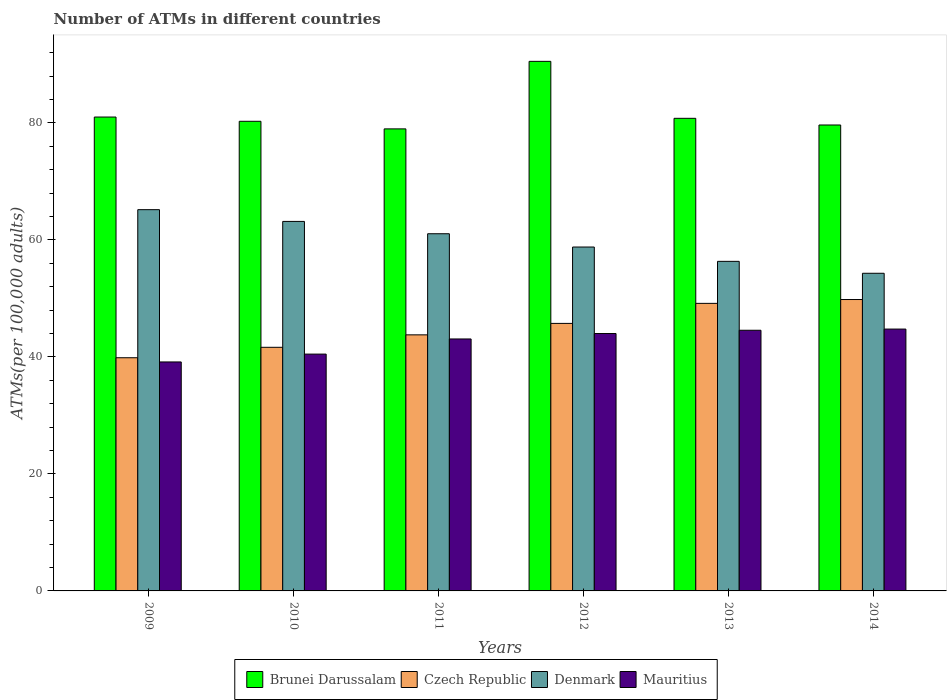How many different coloured bars are there?
Ensure brevity in your answer.  4. How many groups of bars are there?
Make the answer very short. 6. Are the number of bars per tick equal to the number of legend labels?
Provide a succinct answer. Yes. Are the number of bars on each tick of the X-axis equal?
Give a very brief answer. Yes. What is the label of the 6th group of bars from the left?
Your response must be concise. 2014. What is the number of ATMs in Czech Republic in 2014?
Provide a short and direct response. 49.8. Across all years, what is the maximum number of ATMs in Czech Republic?
Offer a terse response. 49.8. Across all years, what is the minimum number of ATMs in Mauritius?
Make the answer very short. 39.13. In which year was the number of ATMs in Denmark maximum?
Provide a succinct answer. 2009. In which year was the number of ATMs in Brunei Darussalam minimum?
Make the answer very short. 2011. What is the total number of ATMs in Denmark in the graph?
Give a very brief answer. 358.73. What is the difference between the number of ATMs in Brunei Darussalam in 2010 and that in 2011?
Provide a short and direct response. 1.3. What is the difference between the number of ATMs in Denmark in 2014 and the number of ATMs in Mauritius in 2009?
Keep it short and to the point. 15.15. What is the average number of ATMs in Denmark per year?
Ensure brevity in your answer.  59.79. In the year 2012, what is the difference between the number of ATMs in Mauritius and number of ATMs in Brunei Darussalam?
Offer a very short reply. -46.52. In how many years, is the number of ATMs in Czech Republic greater than 68?
Make the answer very short. 0. What is the ratio of the number of ATMs in Brunei Darussalam in 2013 to that in 2014?
Provide a short and direct response. 1.01. Is the number of ATMs in Czech Republic in 2009 less than that in 2013?
Your answer should be compact. Yes. What is the difference between the highest and the second highest number of ATMs in Denmark?
Provide a short and direct response. 2.01. What is the difference between the highest and the lowest number of ATMs in Mauritius?
Make the answer very short. 5.62. Is the sum of the number of ATMs in Czech Republic in 2009 and 2012 greater than the maximum number of ATMs in Brunei Darussalam across all years?
Offer a terse response. No. Is it the case that in every year, the sum of the number of ATMs in Brunei Darussalam and number of ATMs in Denmark is greater than the sum of number of ATMs in Mauritius and number of ATMs in Czech Republic?
Provide a succinct answer. No. What does the 2nd bar from the left in 2010 represents?
Your answer should be compact. Czech Republic. How many years are there in the graph?
Keep it short and to the point. 6. Does the graph contain grids?
Offer a terse response. No. What is the title of the graph?
Ensure brevity in your answer.  Number of ATMs in different countries. What is the label or title of the Y-axis?
Your answer should be compact. ATMs(per 100,0 adults). What is the ATMs(per 100,000 adults) of Brunei Darussalam in 2009?
Make the answer very short. 80.99. What is the ATMs(per 100,000 adults) of Czech Republic in 2009?
Provide a short and direct response. 39.85. What is the ATMs(per 100,000 adults) in Denmark in 2009?
Keep it short and to the point. 65.16. What is the ATMs(per 100,000 adults) in Mauritius in 2009?
Provide a short and direct response. 39.13. What is the ATMs(per 100,000 adults) in Brunei Darussalam in 2010?
Provide a short and direct response. 80.26. What is the ATMs(per 100,000 adults) of Czech Republic in 2010?
Your answer should be very brief. 41.63. What is the ATMs(per 100,000 adults) in Denmark in 2010?
Keep it short and to the point. 63.15. What is the ATMs(per 100,000 adults) of Mauritius in 2010?
Your answer should be compact. 40.47. What is the ATMs(per 100,000 adults) in Brunei Darussalam in 2011?
Give a very brief answer. 78.96. What is the ATMs(per 100,000 adults) in Czech Republic in 2011?
Your response must be concise. 43.76. What is the ATMs(per 100,000 adults) in Denmark in 2011?
Your response must be concise. 61.04. What is the ATMs(per 100,000 adults) of Mauritius in 2011?
Ensure brevity in your answer.  43.06. What is the ATMs(per 100,000 adults) of Brunei Darussalam in 2012?
Offer a terse response. 90.5. What is the ATMs(per 100,000 adults) of Czech Republic in 2012?
Provide a succinct answer. 45.72. What is the ATMs(per 100,000 adults) of Denmark in 2012?
Provide a succinct answer. 58.77. What is the ATMs(per 100,000 adults) in Mauritius in 2012?
Give a very brief answer. 43.99. What is the ATMs(per 100,000 adults) of Brunei Darussalam in 2013?
Offer a terse response. 80.77. What is the ATMs(per 100,000 adults) of Czech Republic in 2013?
Give a very brief answer. 49.14. What is the ATMs(per 100,000 adults) of Denmark in 2013?
Keep it short and to the point. 56.32. What is the ATMs(per 100,000 adults) in Mauritius in 2013?
Offer a very short reply. 44.55. What is the ATMs(per 100,000 adults) in Brunei Darussalam in 2014?
Offer a terse response. 79.63. What is the ATMs(per 100,000 adults) of Czech Republic in 2014?
Provide a succinct answer. 49.8. What is the ATMs(per 100,000 adults) in Denmark in 2014?
Your response must be concise. 54.29. What is the ATMs(per 100,000 adults) in Mauritius in 2014?
Your response must be concise. 44.75. Across all years, what is the maximum ATMs(per 100,000 adults) in Brunei Darussalam?
Your answer should be very brief. 90.5. Across all years, what is the maximum ATMs(per 100,000 adults) in Czech Republic?
Offer a terse response. 49.8. Across all years, what is the maximum ATMs(per 100,000 adults) of Denmark?
Offer a very short reply. 65.16. Across all years, what is the maximum ATMs(per 100,000 adults) in Mauritius?
Offer a terse response. 44.75. Across all years, what is the minimum ATMs(per 100,000 adults) of Brunei Darussalam?
Provide a succinct answer. 78.96. Across all years, what is the minimum ATMs(per 100,000 adults) in Czech Republic?
Give a very brief answer. 39.85. Across all years, what is the minimum ATMs(per 100,000 adults) in Denmark?
Ensure brevity in your answer.  54.29. Across all years, what is the minimum ATMs(per 100,000 adults) in Mauritius?
Your answer should be compact. 39.13. What is the total ATMs(per 100,000 adults) in Brunei Darussalam in the graph?
Your answer should be very brief. 491.11. What is the total ATMs(per 100,000 adults) in Czech Republic in the graph?
Your answer should be compact. 269.91. What is the total ATMs(per 100,000 adults) in Denmark in the graph?
Your response must be concise. 358.73. What is the total ATMs(per 100,000 adults) in Mauritius in the graph?
Your answer should be compact. 255.95. What is the difference between the ATMs(per 100,000 adults) in Brunei Darussalam in 2009 and that in 2010?
Keep it short and to the point. 0.73. What is the difference between the ATMs(per 100,000 adults) of Czech Republic in 2009 and that in 2010?
Give a very brief answer. -1.78. What is the difference between the ATMs(per 100,000 adults) of Denmark in 2009 and that in 2010?
Ensure brevity in your answer.  2.01. What is the difference between the ATMs(per 100,000 adults) in Mauritius in 2009 and that in 2010?
Keep it short and to the point. -1.34. What is the difference between the ATMs(per 100,000 adults) of Brunei Darussalam in 2009 and that in 2011?
Make the answer very short. 2.02. What is the difference between the ATMs(per 100,000 adults) in Czech Republic in 2009 and that in 2011?
Give a very brief answer. -3.91. What is the difference between the ATMs(per 100,000 adults) in Denmark in 2009 and that in 2011?
Provide a short and direct response. 4.11. What is the difference between the ATMs(per 100,000 adults) of Mauritius in 2009 and that in 2011?
Provide a succinct answer. -3.93. What is the difference between the ATMs(per 100,000 adults) of Brunei Darussalam in 2009 and that in 2012?
Offer a terse response. -9.52. What is the difference between the ATMs(per 100,000 adults) in Czech Republic in 2009 and that in 2012?
Make the answer very short. -5.87. What is the difference between the ATMs(per 100,000 adults) of Denmark in 2009 and that in 2012?
Provide a short and direct response. 6.38. What is the difference between the ATMs(per 100,000 adults) in Mauritius in 2009 and that in 2012?
Your answer should be compact. -4.86. What is the difference between the ATMs(per 100,000 adults) in Brunei Darussalam in 2009 and that in 2013?
Offer a terse response. 0.22. What is the difference between the ATMs(per 100,000 adults) of Czech Republic in 2009 and that in 2013?
Your answer should be compact. -9.29. What is the difference between the ATMs(per 100,000 adults) in Denmark in 2009 and that in 2013?
Ensure brevity in your answer.  8.83. What is the difference between the ATMs(per 100,000 adults) in Mauritius in 2009 and that in 2013?
Make the answer very short. -5.41. What is the difference between the ATMs(per 100,000 adults) of Brunei Darussalam in 2009 and that in 2014?
Your answer should be very brief. 1.36. What is the difference between the ATMs(per 100,000 adults) of Czech Republic in 2009 and that in 2014?
Ensure brevity in your answer.  -9.95. What is the difference between the ATMs(per 100,000 adults) of Denmark in 2009 and that in 2014?
Make the answer very short. 10.87. What is the difference between the ATMs(per 100,000 adults) in Mauritius in 2009 and that in 2014?
Provide a succinct answer. -5.62. What is the difference between the ATMs(per 100,000 adults) in Brunei Darussalam in 2010 and that in 2011?
Provide a succinct answer. 1.3. What is the difference between the ATMs(per 100,000 adults) in Czech Republic in 2010 and that in 2011?
Offer a terse response. -2.13. What is the difference between the ATMs(per 100,000 adults) in Denmark in 2010 and that in 2011?
Your response must be concise. 2.11. What is the difference between the ATMs(per 100,000 adults) in Mauritius in 2010 and that in 2011?
Offer a terse response. -2.59. What is the difference between the ATMs(per 100,000 adults) of Brunei Darussalam in 2010 and that in 2012?
Offer a terse response. -10.24. What is the difference between the ATMs(per 100,000 adults) in Czech Republic in 2010 and that in 2012?
Offer a very short reply. -4.09. What is the difference between the ATMs(per 100,000 adults) of Denmark in 2010 and that in 2012?
Offer a very short reply. 4.38. What is the difference between the ATMs(per 100,000 adults) in Mauritius in 2010 and that in 2012?
Provide a short and direct response. -3.52. What is the difference between the ATMs(per 100,000 adults) in Brunei Darussalam in 2010 and that in 2013?
Provide a succinct answer. -0.51. What is the difference between the ATMs(per 100,000 adults) in Czech Republic in 2010 and that in 2013?
Keep it short and to the point. -7.51. What is the difference between the ATMs(per 100,000 adults) in Denmark in 2010 and that in 2013?
Offer a terse response. 6.83. What is the difference between the ATMs(per 100,000 adults) of Mauritius in 2010 and that in 2013?
Your response must be concise. -4.07. What is the difference between the ATMs(per 100,000 adults) in Brunei Darussalam in 2010 and that in 2014?
Your response must be concise. 0.63. What is the difference between the ATMs(per 100,000 adults) in Czech Republic in 2010 and that in 2014?
Your answer should be very brief. -8.16. What is the difference between the ATMs(per 100,000 adults) in Denmark in 2010 and that in 2014?
Offer a terse response. 8.86. What is the difference between the ATMs(per 100,000 adults) in Mauritius in 2010 and that in 2014?
Your answer should be very brief. -4.28. What is the difference between the ATMs(per 100,000 adults) in Brunei Darussalam in 2011 and that in 2012?
Your answer should be very brief. -11.54. What is the difference between the ATMs(per 100,000 adults) of Czech Republic in 2011 and that in 2012?
Offer a terse response. -1.96. What is the difference between the ATMs(per 100,000 adults) of Denmark in 2011 and that in 2012?
Ensure brevity in your answer.  2.27. What is the difference between the ATMs(per 100,000 adults) in Mauritius in 2011 and that in 2012?
Your response must be concise. -0.93. What is the difference between the ATMs(per 100,000 adults) of Brunei Darussalam in 2011 and that in 2013?
Provide a short and direct response. -1.81. What is the difference between the ATMs(per 100,000 adults) in Czech Republic in 2011 and that in 2013?
Offer a very short reply. -5.38. What is the difference between the ATMs(per 100,000 adults) of Denmark in 2011 and that in 2013?
Offer a terse response. 4.72. What is the difference between the ATMs(per 100,000 adults) in Mauritius in 2011 and that in 2013?
Give a very brief answer. -1.49. What is the difference between the ATMs(per 100,000 adults) in Brunei Darussalam in 2011 and that in 2014?
Your response must be concise. -0.67. What is the difference between the ATMs(per 100,000 adults) of Czech Republic in 2011 and that in 2014?
Give a very brief answer. -6.04. What is the difference between the ATMs(per 100,000 adults) in Denmark in 2011 and that in 2014?
Your response must be concise. 6.76. What is the difference between the ATMs(per 100,000 adults) of Mauritius in 2011 and that in 2014?
Give a very brief answer. -1.69. What is the difference between the ATMs(per 100,000 adults) in Brunei Darussalam in 2012 and that in 2013?
Give a very brief answer. 9.73. What is the difference between the ATMs(per 100,000 adults) of Czech Republic in 2012 and that in 2013?
Provide a succinct answer. -3.42. What is the difference between the ATMs(per 100,000 adults) in Denmark in 2012 and that in 2013?
Keep it short and to the point. 2.45. What is the difference between the ATMs(per 100,000 adults) of Mauritius in 2012 and that in 2013?
Provide a short and direct response. -0.56. What is the difference between the ATMs(per 100,000 adults) of Brunei Darussalam in 2012 and that in 2014?
Offer a very short reply. 10.88. What is the difference between the ATMs(per 100,000 adults) in Czech Republic in 2012 and that in 2014?
Provide a short and direct response. -4.08. What is the difference between the ATMs(per 100,000 adults) in Denmark in 2012 and that in 2014?
Provide a succinct answer. 4.49. What is the difference between the ATMs(per 100,000 adults) of Mauritius in 2012 and that in 2014?
Keep it short and to the point. -0.76. What is the difference between the ATMs(per 100,000 adults) of Brunei Darussalam in 2013 and that in 2014?
Ensure brevity in your answer.  1.14. What is the difference between the ATMs(per 100,000 adults) of Czech Republic in 2013 and that in 2014?
Provide a succinct answer. -0.66. What is the difference between the ATMs(per 100,000 adults) in Denmark in 2013 and that in 2014?
Offer a terse response. 2.04. What is the difference between the ATMs(per 100,000 adults) of Mauritius in 2013 and that in 2014?
Make the answer very short. -0.2. What is the difference between the ATMs(per 100,000 adults) in Brunei Darussalam in 2009 and the ATMs(per 100,000 adults) in Czech Republic in 2010?
Give a very brief answer. 39.35. What is the difference between the ATMs(per 100,000 adults) of Brunei Darussalam in 2009 and the ATMs(per 100,000 adults) of Denmark in 2010?
Ensure brevity in your answer.  17.84. What is the difference between the ATMs(per 100,000 adults) of Brunei Darussalam in 2009 and the ATMs(per 100,000 adults) of Mauritius in 2010?
Ensure brevity in your answer.  40.51. What is the difference between the ATMs(per 100,000 adults) of Czech Republic in 2009 and the ATMs(per 100,000 adults) of Denmark in 2010?
Your response must be concise. -23.3. What is the difference between the ATMs(per 100,000 adults) in Czech Republic in 2009 and the ATMs(per 100,000 adults) in Mauritius in 2010?
Ensure brevity in your answer.  -0.62. What is the difference between the ATMs(per 100,000 adults) of Denmark in 2009 and the ATMs(per 100,000 adults) of Mauritius in 2010?
Keep it short and to the point. 24.68. What is the difference between the ATMs(per 100,000 adults) in Brunei Darussalam in 2009 and the ATMs(per 100,000 adults) in Czech Republic in 2011?
Offer a very short reply. 37.22. What is the difference between the ATMs(per 100,000 adults) in Brunei Darussalam in 2009 and the ATMs(per 100,000 adults) in Denmark in 2011?
Your response must be concise. 19.94. What is the difference between the ATMs(per 100,000 adults) of Brunei Darussalam in 2009 and the ATMs(per 100,000 adults) of Mauritius in 2011?
Keep it short and to the point. 37.92. What is the difference between the ATMs(per 100,000 adults) of Czech Republic in 2009 and the ATMs(per 100,000 adults) of Denmark in 2011?
Keep it short and to the point. -21.19. What is the difference between the ATMs(per 100,000 adults) of Czech Republic in 2009 and the ATMs(per 100,000 adults) of Mauritius in 2011?
Your answer should be compact. -3.21. What is the difference between the ATMs(per 100,000 adults) in Denmark in 2009 and the ATMs(per 100,000 adults) in Mauritius in 2011?
Your response must be concise. 22.1. What is the difference between the ATMs(per 100,000 adults) of Brunei Darussalam in 2009 and the ATMs(per 100,000 adults) of Czech Republic in 2012?
Make the answer very short. 35.27. What is the difference between the ATMs(per 100,000 adults) in Brunei Darussalam in 2009 and the ATMs(per 100,000 adults) in Denmark in 2012?
Keep it short and to the point. 22.21. What is the difference between the ATMs(per 100,000 adults) in Brunei Darussalam in 2009 and the ATMs(per 100,000 adults) in Mauritius in 2012?
Your answer should be very brief. 37. What is the difference between the ATMs(per 100,000 adults) of Czech Republic in 2009 and the ATMs(per 100,000 adults) of Denmark in 2012?
Your answer should be compact. -18.92. What is the difference between the ATMs(per 100,000 adults) in Czech Republic in 2009 and the ATMs(per 100,000 adults) in Mauritius in 2012?
Provide a short and direct response. -4.14. What is the difference between the ATMs(per 100,000 adults) in Denmark in 2009 and the ATMs(per 100,000 adults) in Mauritius in 2012?
Your answer should be very brief. 21.17. What is the difference between the ATMs(per 100,000 adults) in Brunei Darussalam in 2009 and the ATMs(per 100,000 adults) in Czech Republic in 2013?
Provide a succinct answer. 31.84. What is the difference between the ATMs(per 100,000 adults) in Brunei Darussalam in 2009 and the ATMs(per 100,000 adults) in Denmark in 2013?
Ensure brevity in your answer.  24.66. What is the difference between the ATMs(per 100,000 adults) of Brunei Darussalam in 2009 and the ATMs(per 100,000 adults) of Mauritius in 2013?
Keep it short and to the point. 36.44. What is the difference between the ATMs(per 100,000 adults) of Czech Republic in 2009 and the ATMs(per 100,000 adults) of Denmark in 2013?
Your answer should be compact. -16.47. What is the difference between the ATMs(per 100,000 adults) in Czech Republic in 2009 and the ATMs(per 100,000 adults) in Mauritius in 2013?
Your response must be concise. -4.7. What is the difference between the ATMs(per 100,000 adults) in Denmark in 2009 and the ATMs(per 100,000 adults) in Mauritius in 2013?
Offer a very short reply. 20.61. What is the difference between the ATMs(per 100,000 adults) in Brunei Darussalam in 2009 and the ATMs(per 100,000 adults) in Czech Republic in 2014?
Make the answer very short. 31.19. What is the difference between the ATMs(per 100,000 adults) of Brunei Darussalam in 2009 and the ATMs(per 100,000 adults) of Denmark in 2014?
Keep it short and to the point. 26.7. What is the difference between the ATMs(per 100,000 adults) in Brunei Darussalam in 2009 and the ATMs(per 100,000 adults) in Mauritius in 2014?
Offer a very short reply. 36.24. What is the difference between the ATMs(per 100,000 adults) in Czech Republic in 2009 and the ATMs(per 100,000 adults) in Denmark in 2014?
Make the answer very short. -14.43. What is the difference between the ATMs(per 100,000 adults) of Czech Republic in 2009 and the ATMs(per 100,000 adults) of Mauritius in 2014?
Provide a short and direct response. -4.9. What is the difference between the ATMs(per 100,000 adults) of Denmark in 2009 and the ATMs(per 100,000 adults) of Mauritius in 2014?
Provide a short and direct response. 20.41. What is the difference between the ATMs(per 100,000 adults) in Brunei Darussalam in 2010 and the ATMs(per 100,000 adults) in Czech Republic in 2011?
Make the answer very short. 36.5. What is the difference between the ATMs(per 100,000 adults) of Brunei Darussalam in 2010 and the ATMs(per 100,000 adults) of Denmark in 2011?
Keep it short and to the point. 19.22. What is the difference between the ATMs(per 100,000 adults) of Brunei Darussalam in 2010 and the ATMs(per 100,000 adults) of Mauritius in 2011?
Provide a short and direct response. 37.2. What is the difference between the ATMs(per 100,000 adults) of Czech Republic in 2010 and the ATMs(per 100,000 adults) of Denmark in 2011?
Provide a short and direct response. -19.41. What is the difference between the ATMs(per 100,000 adults) of Czech Republic in 2010 and the ATMs(per 100,000 adults) of Mauritius in 2011?
Ensure brevity in your answer.  -1.43. What is the difference between the ATMs(per 100,000 adults) in Denmark in 2010 and the ATMs(per 100,000 adults) in Mauritius in 2011?
Ensure brevity in your answer.  20.09. What is the difference between the ATMs(per 100,000 adults) of Brunei Darussalam in 2010 and the ATMs(per 100,000 adults) of Czech Republic in 2012?
Your response must be concise. 34.54. What is the difference between the ATMs(per 100,000 adults) of Brunei Darussalam in 2010 and the ATMs(per 100,000 adults) of Denmark in 2012?
Your answer should be very brief. 21.49. What is the difference between the ATMs(per 100,000 adults) of Brunei Darussalam in 2010 and the ATMs(per 100,000 adults) of Mauritius in 2012?
Offer a terse response. 36.27. What is the difference between the ATMs(per 100,000 adults) in Czech Republic in 2010 and the ATMs(per 100,000 adults) in Denmark in 2012?
Ensure brevity in your answer.  -17.14. What is the difference between the ATMs(per 100,000 adults) in Czech Republic in 2010 and the ATMs(per 100,000 adults) in Mauritius in 2012?
Ensure brevity in your answer.  -2.35. What is the difference between the ATMs(per 100,000 adults) in Denmark in 2010 and the ATMs(per 100,000 adults) in Mauritius in 2012?
Provide a short and direct response. 19.16. What is the difference between the ATMs(per 100,000 adults) of Brunei Darussalam in 2010 and the ATMs(per 100,000 adults) of Czech Republic in 2013?
Give a very brief answer. 31.12. What is the difference between the ATMs(per 100,000 adults) in Brunei Darussalam in 2010 and the ATMs(per 100,000 adults) in Denmark in 2013?
Offer a very short reply. 23.94. What is the difference between the ATMs(per 100,000 adults) of Brunei Darussalam in 2010 and the ATMs(per 100,000 adults) of Mauritius in 2013?
Offer a terse response. 35.71. What is the difference between the ATMs(per 100,000 adults) of Czech Republic in 2010 and the ATMs(per 100,000 adults) of Denmark in 2013?
Keep it short and to the point. -14.69. What is the difference between the ATMs(per 100,000 adults) of Czech Republic in 2010 and the ATMs(per 100,000 adults) of Mauritius in 2013?
Your response must be concise. -2.91. What is the difference between the ATMs(per 100,000 adults) of Denmark in 2010 and the ATMs(per 100,000 adults) of Mauritius in 2013?
Your response must be concise. 18.6. What is the difference between the ATMs(per 100,000 adults) of Brunei Darussalam in 2010 and the ATMs(per 100,000 adults) of Czech Republic in 2014?
Your response must be concise. 30.46. What is the difference between the ATMs(per 100,000 adults) of Brunei Darussalam in 2010 and the ATMs(per 100,000 adults) of Denmark in 2014?
Provide a succinct answer. 25.97. What is the difference between the ATMs(per 100,000 adults) in Brunei Darussalam in 2010 and the ATMs(per 100,000 adults) in Mauritius in 2014?
Make the answer very short. 35.51. What is the difference between the ATMs(per 100,000 adults) of Czech Republic in 2010 and the ATMs(per 100,000 adults) of Denmark in 2014?
Your answer should be compact. -12.65. What is the difference between the ATMs(per 100,000 adults) of Czech Republic in 2010 and the ATMs(per 100,000 adults) of Mauritius in 2014?
Your answer should be very brief. -3.12. What is the difference between the ATMs(per 100,000 adults) in Denmark in 2010 and the ATMs(per 100,000 adults) in Mauritius in 2014?
Your answer should be very brief. 18.4. What is the difference between the ATMs(per 100,000 adults) of Brunei Darussalam in 2011 and the ATMs(per 100,000 adults) of Czech Republic in 2012?
Give a very brief answer. 33.24. What is the difference between the ATMs(per 100,000 adults) of Brunei Darussalam in 2011 and the ATMs(per 100,000 adults) of Denmark in 2012?
Ensure brevity in your answer.  20.19. What is the difference between the ATMs(per 100,000 adults) in Brunei Darussalam in 2011 and the ATMs(per 100,000 adults) in Mauritius in 2012?
Provide a short and direct response. 34.97. What is the difference between the ATMs(per 100,000 adults) of Czech Republic in 2011 and the ATMs(per 100,000 adults) of Denmark in 2012?
Offer a very short reply. -15.01. What is the difference between the ATMs(per 100,000 adults) in Czech Republic in 2011 and the ATMs(per 100,000 adults) in Mauritius in 2012?
Ensure brevity in your answer.  -0.23. What is the difference between the ATMs(per 100,000 adults) in Denmark in 2011 and the ATMs(per 100,000 adults) in Mauritius in 2012?
Your answer should be very brief. 17.05. What is the difference between the ATMs(per 100,000 adults) in Brunei Darussalam in 2011 and the ATMs(per 100,000 adults) in Czech Republic in 2013?
Keep it short and to the point. 29.82. What is the difference between the ATMs(per 100,000 adults) in Brunei Darussalam in 2011 and the ATMs(per 100,000 adults) in Denmark in 2013?
Give a very brief answer. 22.64. What is the difference between the ATMs(per 100,000 adults) in Brunei Darussalam in 2011 and the ATMs(per 100,000 adults) in Mauritius in 2013?
Keep it short and to the point. 34.41. What is the difference between the ATMs(per 100,000 adults) of Czech Republic in 2011 and the ATMs(per 100,000 adults) of Denmark in 2013?
Your response must be concise. -12.56. What is the difference between the ATMs(per 100,000 adults) in Czech Republic in 2011 and the ATMs(per 100,000 adults) in Mauritius in 2013?
Ensure brevity in your answer.  -0.78. What is the difference between the ATMs(per 100,000 adults) in Denmark in 2011 and the ATMs(per 100,000 adults) in Mauritius in 2013?
Offer a terse response. 16.5. What is the difference between the ATMs(per 100,000 adults) in Brunei Darussalam in 2011 and the ATMs(per 100,000 adults) in Czech Republic in 2014?
Your answer should be very brief. 29.16. What is the difference between the ATMs(per 100,000 adults) in Brunei Darussalam in 2011 and the ATMs(per 100,000 adults) in Denmark in 2014?
Provide a short and direct response. 24.68. What is the difference between the ATMs(per 100,000 adults) in Brunei Darussalam in 2011 and the ATMs(per 100,000 adults) in Mauritius in 2014?
Provide a succinct answer. 34.21. What is the difference between the ATMs(per 100,000 adults) of Czech Republic in 2011 and the ATMs(per 100,000 adults) of Denmark in 2014?
Your answer should be compact. -10.52. What is the difference between the ATMs(per 100,000 adults) of Czech Republic in 2011 and the ATMs(per 100,000 adults) of Mauritius in 2014?
Keep it short and to the point. -0.99. What is the difference between the ATMs(per 100,000 adults) in Denmark in 2011 and the ATMs(per 100,000 adults) in Mauritius in 2014?
Your response must be concise. 16.29. What is the difference between the ATMs(per 100,000 adults) in Brunei Darussalam in 2012 and the ATMs(per 100,000 adults) in Czech Republic in 2013?
Offer a terse response. 41.36. What is the difference between the ATMs(per 100,000 adults) of Brunei Darussalam in 2012 and the ATMs(per 100,000 adults) of Denmark in 2013?
Offer a very short reply. 34.18. What is the difference between the ATMs(per 100,000 adults) in Brunei Darussalam in 2012 and the ATMs(per 100,000 adults) in Mauritius in 2013?
Give a very brief answer. 45.96. What is the difference between the ATMs(per 100,000 adults) of Czech Republic in 2012 and the ATMs(per 100,000 adults) of Denmark in 2013?
Give a very brief answer. -10.6. What is the difference between the ATMs(per 100,000 adults) of Czech Republic in 2012 and the ATMs(per 100,000 adults) of Mauritius in 2013?
Ensure brevity in your answer.  1.17. What is the difference between the ATMs(per 100,000 adults) in Denmark in 2012 and the ATMs(per 100,000 adults) in Mauritius in 2013?
Offer a terse response. 14.23. What is the difference between the ATMs(per 100,000 adults) in Brunei Darussalam in 2012 and the ATMs(per 100,000 adults) in Czech Republic in 2014?
Your answer should be very brief. 40.7. What is the difference between the ATMs(per 100,000 adults) of Brunei Darussalam in 2012 and the ATMs(per 100,000 adults) of Denmark in 2014?
Offer a terse response. 36.22. What is the difference between the ATMs(per 100,000 adults) of Brunei Darussalam in 2012 and the ATMs(per 100,000 adults) of Mauritius in 2014?
Provide a succinct answer. 45.75. What is the difference between the ATMs(per 100,000 adults) of Czech Republic in 2012 and the ATMs(per 100,000 adults) of Denmark in 2014?
Offer a terse response. -8.57. What is the difference between the ATMs(per 100,000 adults) in Czech Republic in 2012 and the ATMs(per 100,000 adults) in Mauritius in 2014?
Make the answer very short. 0.97. What is the difference between the ATMs(per 100,000 adults) of Denmark in 2012 and the ATMs(per 100,000 adults) of Mauritius in 2014?
Your response must be concise. 14.02. What is the difference between the ATMs(per 100,000 adults) in Brunei Darussalam in 2013 and the ATMs(per 100,000 adults) in Czech Republic in 2014?
Your answer should be compact. 30.97. What is the difference between the ATMs(per 100,000 adults) of Brunei Darussalam in 2013 and the ATMs(per 100,000 adults) of Denmark in 2014?
Provide a succinct answer. 26.48. What is the difference between the ATMs(per 100,000 adults) of Brunei Darussalam in 2013 and the ATMs(per 100,000 adults) of Mauritius in 2014?
Keep it short and to the point. 36.02. What is the difference between the ATMs(per 100,000 adults) of Czech Republic in 2013 and the ATMs(per 100,000 adults) of Denmark in 2014?
Keep it short and to the point. -5.14. What is the difference between the ATMs(per 100,000 adults) in Czech Republic in 2013 and the ATMs(per 100,000 adults) in Mauritius in 2014?
Offer a very short reply. 4.39. What is the difference between the ATMs(per 100,000 adults) of Denmark in 2013 and the ATMs(per 100,000 adults) of Mauritius in 2014?
Provide a succinct answer. 11.57. What is the average ATMs(per 100,000 adults) of Brunei Darussalam per year?
Your answer should be compact. 81.85. What is the average ATMs(per 100,000 adults) of Czech Republic per year?
Offer a terse response. 44.98. What is the average ATMs(per 100,000 adults) of Denmark per year?
Your answer should be compact. 59.79. What is the average ATMs(per 100,000 adults) in Mauritius per year?
Ensure brevity in your answer.  42.66. In the year 2009, what is the difference between the ATMs(per 100,000 adults) in Brunei Darussalam and ATMs(per 100,000 adults) in Czech Republic?
Keep it short and to the point. 41.13. In the year 2009, what is the difference between the ATMs(per 100,000 adults) in Brunei Darussalam and ATMs(per 100,000 adults) in Denmark?
Keep it short and to the point. 15.83. In the year 2009, what is the difference between the ATMs(per 100,000 adults) in Brunei Darussalam and ATMs(per 100,000 adults) in Mauritius?
Ensure brevity in your answer.  41.85. In the year 2009, what is the difference between the ATMs(per 100,000 adults) of Czech Republic and ATMs(per 100,000 adults) of Denmark?
Ensure brevity in your answer.  -25.31. In the year 2009, what is the difference between the ATMs(per 100,000 adults) of Czech Republic and ATMs(per 100,000 adults) of Mauritius?
Provide a short and direct response. 0.72. In the year 2009, what is the difference between the ATMs(per 100,000 adults) in Denmark and ATMs(per 100,000 adults) in Mauritius?
Your answer should be compact. 26.02. In the year 2010, what is the difference between the ATMs(per 100,000 adults) in Brunei Darussalam and ATMs(per 100,000 adults) in Czech Republic?
Keep it short and to the point. 38.63. In the year 2010, what is the difference between the ATMs(per 100,000 adults) of Brunei Darussalam and ATMs(per 100,000 adults) of Denmark?
Give a very brief answer. 17.11. In the year 2010, what is the difference between the ATMs(per 100,000 adults) in Brunei Darussalam and ATMs(per 100,000 adults) in Mauritius?
Give a very brief answer. 39.79. In the year 2010, what is the difference between the ATMs(per 100,000 adults) in Czech Republic and ATMs(per 100,000 adults) in Denmark?
Give a very brief answer. -21.51. In the year 2010, what is the difference between the ATMs(per 100,000 adults) of Czech Republic and ATMs(per 100,000 adults) of Mauritius?
Offer a very short reply. 1.16. In the year 2010, what is the difference between the ATMs(per 100,000 adults) in Denmark and ATMs(per 100,000 adults) in Mauritius?
Your response must be concise. 22.68. In the year 2011, what is the difference between the ATMs(per 100,000 adults) in Brunei Darussalam and ATMs(per 100,000 adults) in Czech Republic?
Your response must be concise. 35.2. In the year 2011, what is the difference between the ATMs(per 100,000 adults) in Brunei Darussalam and ATMs(per 100,000 adults) in Denmark?
Your answer should be very brief. 17.92. In the year 2011, what is the difference between the ATMs(per 100,000 adults) of Brunei Darussalam and ATMs(per 100,000 adults) of Mauritius?
Keep it short and to the point. 35.9. In the year 2011, what is the difference between the ATMs(per 100,000 adults) of Czech Republic and ATMs(per 100,000 adults) of Denmark?
Offer a terse response. -17.28. In the year 2011, what is the difference between the ATMs(per 100,000 adults) in Czech Republic and ATMs(per 100,000 adults) in Mauritius?
Your response must be concise. 0.7. In the year 2011, what is the difference between the ATMs(per 100,000 adults) of Denmark and ATMs(per 100,000 adults) of Mauritius?
Offer a very short reply. 17.98. In the year 2012, what is the difference between the ATMs(per 100,000 adults) of Brunei Darussalam and ATMs(per 100,000 adults) of Czech Republic?
Offer a terse response. 44.78. In the year 2012, what is the difference between the ATMs(per 100,000 adults) in Brunei Darussalam and ATMs(per 100,000 adults) in Denmark?
Offer a very short reply. 31.73. In the year 2012, what is the difference between the ATMs(per 100,000 adults) in Brunei Darussalam and ATMs(per 100,000 adults) in Mauritius?
Provide a short and direct response. 46.52. In the year 2012, what is the difference between the ATMs(per 100,000 adults) of Czech Republic and ATMs(per 100,000 adults) of Denmark?
Offer a very short reply. -13.05. In the year 2012, what is the difference between the ATMs(per 100,000 adults) of Czech Republic and ATMs(per 100,000 adults) of Mauritius?
Give a very brief answer. 1.73. In the year 2012, what is the difference between the ATMs(per 100,000 adults) in Denmark and ATMs(per 100,000 adults) in Mauritius?
Keep it short and to the point. 14.78. In the year 2013, what is the difference between the ATMs(per 100,000 adults) of Brunei Darussalam and ATMs(per 100,000 adults) of Czech Republic?
Give a very brief answer. 31.63. In the year 2013, what is the difference between the ATMs(per 100,000 adults) of Brunei Darussalam and ATMs(per 100,000 adults) of Denmark?
Offer a terse response. 24.45. In the year 2013, what is the difference between the ATMs(per 100,000 adults) of Brunei Darussalam and ATMs(per 100,000 adults) of Mauritius?
Provide a short and direct response. 36.22. In the year 2013, what is the difference between the ATMs(per 100,000 adults) of Czech Republic and ATMs(per 100,000 adults) of Denmark?
Provide a short and direct response. -7.18. In the year 2013, what is the difference between the ATMs(per 100,000 adults) in Czech Republic and ATMs(per 100,000 adults) in Mauritius?
Provide a succinct answer. 4.6. In the year 2013, what is the difference between the ATMs(per 100,000 adults) in Denmark and ATMs(per 100,000 adults) in Mauritius?
Keep it short and to the point. 11.78. In the year 2014, what is the difference between the ATMs(per 100,000 adults) of Brunei Darussalam and ATMs(per 100,000 adults) of Czech Republic?
Offer a terse response. 29.83. In the year 2014, what is the difference between the ATMs(per 100,000 adults) of Brunei Darussalam and ATMs(per 100,000 adults) of Denmark?
Offer a terse response. 25.34. In the year 2014, what is the difference between the ATMs(per 100,000 adults) of Brunei Darussalam and ATMs(per 100,000 adults) of Mauritius?
Provide a short and direct response. 34.88. In the year 2014, what is the difference between the ATMs(per 100,000 adults) in Czech Republic and ATMs(per 100,000 adults) in Denmark?
Make the answer very short. -4.49. In the year 2014, what is the difference between the ATMs(per 100,000 adults) of Czech Republic and ATMs(per 100,000 adults) of Mauritius?
Make the answer very short. 5.05. In the year 2014, what is the difference between the ATMs(per 100,000 adults) in Denmark and ATMs(per 100,000 adults) in Mauritius?
Offer a very short reply. 9.54. What is the ratio of the ATMs(per 100,000 adults) in Brunei Darussalam in 2009 to that in 2010?
Your answer should be very brief. 1.01. What is the ratio of the ATMs(per 100,000 adults) of Czech Republic in 2009 to that in 2010?
Your answer should be very brief. 0.96. What is the ratio of the ATMs(per 100,000 adults) of Denmark in 2009 to that in 2010?
Keep it short and to the point. 1.03. What is the ratio of the ATMs(per 100,000 adults) of Mauritius in 2009 to that in 2010?
Offer a very short reply. 0.97. What is the ratio of the ATMs(per 100,000 adults) in Brunei Darussalam in 2009 to that in 2011?
Your response must be concise. 1.03. What is the ratio of the ATMs(per 100,000 adults) of Czech Republic in 2009 to that in 2011?
Provide a succinct answer. 0.91. What is the ratio of the ATMs(per 100,000 adults) of Denmark in 2009 to that in 2011?
Offer a terse response. 1.07. What is the ratio of the ATMs(per 100,000 adults) of Mauritius in 2009 to that in 2011?
Offer a terse response. 0.91. What is the ratio of the ATMs(per 100,000 adults) in Brunei Darussalam in 2009 to that in 2012?
Give a very brief answer. 0.89. What is the ratio of the ATMs(per 100,000 adults) of Czech Republic in 2009 to that in 2012?
Offer a terse response. 0.87. What is the ratio of the ATMs(per 100,000 adults) in Denmark in 2009 to that in 2012?
Give a very brief answer. 1.11. What is the ratio of the ATMs(per 100,000 adults) in Mauritius in 2009 to that in 2012?
Offer a very short reply. 0.89. What is the ratio of the ATMs(per 100,000 adults) in Brunei Darussalam in 2009 to that in 2013?
Your response must be concise. 1. What is the ratio of the ATMs(per 100,000 adults) of Czech Republic in 2009 to that in 2013?
Offer a very short reply. 0.81. What is the ratio of the ATMs(per 100,000 adults) of Denmark in 2009 to that in 2013?
Offer a very short reply. 1.16. What is the ratio of the ATMs(per 100,000 adults) of Mauritius in 2009 to that in 2013?
Give a very brief answer. 0.88. What is the ratio of the ATMs(per 100,000 adults) of Brunei Darussalam in 2009 to that in 2014?
Provide a succinct answer. 1.02. What is the ratio of the ATMs(per 100,000 adults) of Czech Republic in 2009 to that in 2014?
Give a very brief answer. 0.8. What is the ratio of the ATMs(per 100,000 adults) of Denmark in 2009 to that in 2014?
Keep it short and to the point. 1.2. What is the ratio of the ATMs(per 100,000 adults) in Mauritius in 2009 to that in 2014?
Make the answer very short. 0.87. What is the ratio of the ATMs(per 100,000 adults) in Brunei Darussalam in 2010 to that in 2011?
Your response must be concise. 1.02. What is the ratio of the ATMs(per 100,000 adults) in Czech Republic in 2010 to that in 2011?
Give a very brief answer. 0.95. What is the ratio of the ATMs(per 100,000 adults) in Denmark in 2010 to that in 2011?
Your answer should be very brief. 1.03. What is the ratio of the ATMs(per 100,000 adults) in Mauritius in 2010 to that in 2011?
Offer a terse response. 0.94. What is the ratio of the ATMs(per 100,000 adults) of Brunei Darussalam in 2010 to that in 2012?
Your answer should be very brief. 0.89. What is the ratio of the ATMs(per 100,000 adults) in Czech Republic in 2010 to that in 2012?
Provide a succinct answer. 0.91. What is the ratio of the ATMs(per 100,000 adults) in Denmark in 2010 to that in 2012?
Offer a terse response. 1.07. What is the ratio of the ATMs(per 100,000 adults) of Mauritius in 2010 to that in 2012?
Provide a short and direct response. 0.92. What is the ratio of the ATMs(per 100,000 adults) of Czech Republic in 2010 to that in 2013?
Keep it short and to the point. 0.85. What is the ratio of the ATMs(per 100,000 adults) of Denmark in 2010 to that in 2013?
Keep it short and to the point. 1.12. What is the ratio of the ATMs(per 100,000 adults) of Mauritius in 2010 to that in 2013?
Keep it short and to the point. 0.91. What is the ratio of the ATMs(per 100,000 adults) of Brunei Darussalam in 2010 to that in 2014?
Keep it short and to the point. 1.01. What is the ratio of the ATMs(per 100,000 adults) in Czech Republic in 2010 to that in 2014?
Your answer should be compact. 0.84. What is the ratio of the ATMs(per 100,000 adults) in Denmark in 2010 to that in 2014?
Provide a succinct answer. 1.16. What is the ratio of the ATMs(per 100,000 adults) of Mauritius in 2010 to that in 2014?
Your answer should be very brief. 0.9. What is the ratio of the ATMs(per 100,000 adults) of Brunei Darussalam in 2011 to that in 2012?
Provide a short and direct response. 0.87. What is the ratio of the ATMs(per 100,000 adults) in Czech Republic in 2011 to that in 2012?
Provide a short and direct response. 0.96. What is the ratio of the ATMs(per 100,000 adults) of Denmark in 2011 to that in 2012?
Your answer should be very brief. 1.04. What is the ratio of the ATMs(per 100,000 adults) in Mauritius in 2011 to that in 2012?
Give a very brief answer. 0.98. What is the ratio of the ATMs(per 100,000 adults) in Brunei Darussalam in 2011 to that in 2013?
Offer a terse response. 0.98. What is the ratio of the ATMs(per 100,000 adults) in Czech Republic in 2011 to that in 2013?
Your response must be concise. 0.89. What is the ratio of the ATMs(per 100,000 adults) in Denmark in 2011 to that in 2013?
Make the answer very short. 1.08. What is the ratio of the ATMs(per 100,000 adults) in Mauritius in 2011 to that in 2013?
Your answer should be compact. 0.97. What is the ratio of the ATMs(per 100,000 adults) of Brunei Darussalam in 2011 to that in 2014?
Your answer should be very brief. 0.99. What is the ratio of the ATMs(per 100,000 adults) of Czech Republic in 2011 to that in 2014?
Make the answer very short. 0.88. What is the ratio of the ATMs(per 100,000 adults) in Denmark in 2011 to that in 2014?
Keep it short and to the point. 1.12. What is the ratio of the ATMs(per 100,000 adults) of Mauritius in 2011 to that in 2014?
Your response must be concise. 0.96. What is the ratio of the ATMs(per 100,000 adults) of Brunei Darussalam in 2012 to that in 2013?
Offer a terse response. 1.12. What is the ratio of the ATMs(per 100,000 adults) of Czech Republic in 2012 to that in 2013?
Your answer should be very brief. 0.93. What is the ratio of the ATMs(per 100,000 adults) in Denmark in 2012 to that in 2013?
Offer a very short reply. 1.04. What is the ratio of the ATMs(per 100,000 adults) of Mauritius in 2012 to that in 2013?
Ensure brevity in your answer.  0.99. What is the ratio of the ATMs(per 100,000 adults) in Brunei Darussalam in 2012 to that in 2014?
Provide a succinct answer. 1.14. What is the ratio of the ATMs(per 100,000 adults) of Czech Republic in 2012 to that in 2014?
Your answer should be very brief. 0.92. What is the ratio of the ATMs(per 100,000 adults) in Denmark in 2012 to that in 2014?
Your answer should be compact. 1.08. What is the ratio of the ATMs(per 100,000 adults) of Brunei Darussalam in 2013 to that in 2014?
Offer a terse response. 1.01. What is the ratio of the ATMs(per 100,000 adults) of Czech Republic in 2013 to that in 2014?
Offer a very short reply. 0.99. What is the ratio of the ATMs(per 100,000 adults) of Denmark in 2013 to that in 2014?
Provide a short and direct response. 1.04. What is the ratio of the ATMs(per 100,000 adults) of Mauritius in 2013 to that in 2014?
Provide a succinct answer. 1. What is the difference between the highest and the second highest ATMs(per 100,000 adults) of Brunei Darussalam?
Keep it short and to the point. 9.52. What is the difference between the highest and the second highest ATMs(per 100,000 adults) in Czech Republic?
Your answer should be compact. 0.66. What is the difference between the highest and the second highest ATMs(per 100,000 adults) in Denmark?
Your answer should be very brief. 2.01. What is the difference between the highest and the second highest ATMs(per 100,000 adults) in Mauritius?
Your answer should be compact. 0.2. What is the difference between the highest and the lowest ATMs(per 100,000 adults) in Brunei Darussalam?
Give a very brief answer. 11.54. What is the difference between the highest and the lowest ATMs(per 100,000 adults) in Czech Republic?
Your answer should be compact. 9.95. What is the difference between the highest and the lowest ATMs(per 100,000 adults) in Denmark?
Give a very brief answer. 10.87. What is the difference between the highest and the lowest ATMs(per 100,000 adults) of Mauritius?
Provide a succinct answer. 5.62. 